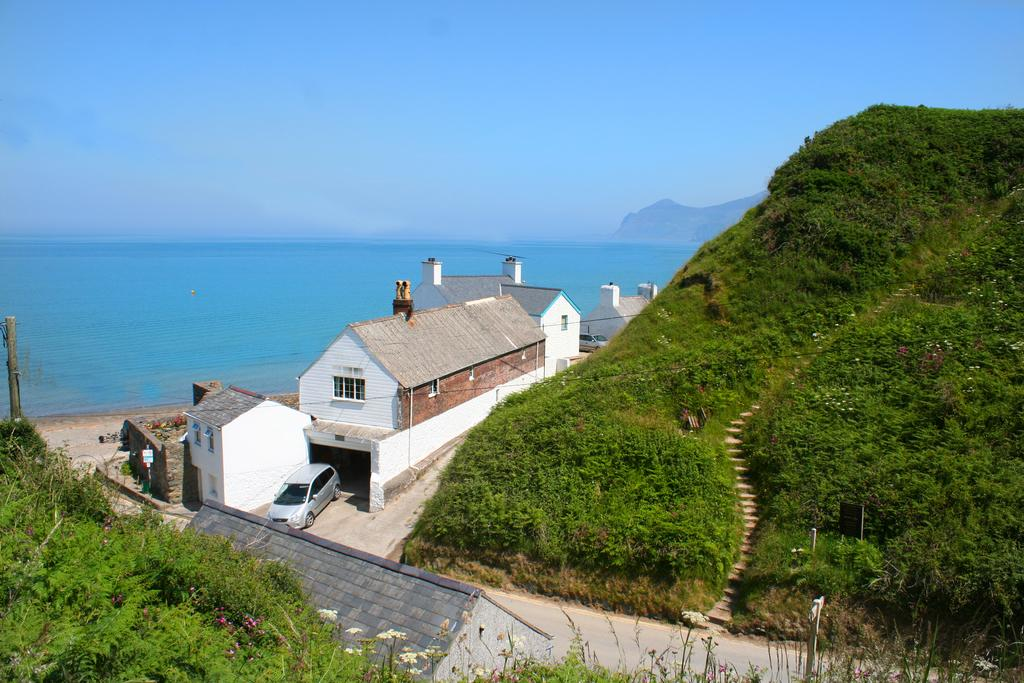What type of structures can be seen in the image? There are houses in the image. What is the main pathway visible in the image? There is a road in the image. What natural features are present in the image? Mountains covered with plants are visible in the image, and the background includes a sea. What part of the sky is visible? The top of the image contains the sky. Where is the mom in the image? There is no mom present in the image. What type of power source is visible in the image? There is no power source visible in the image. 